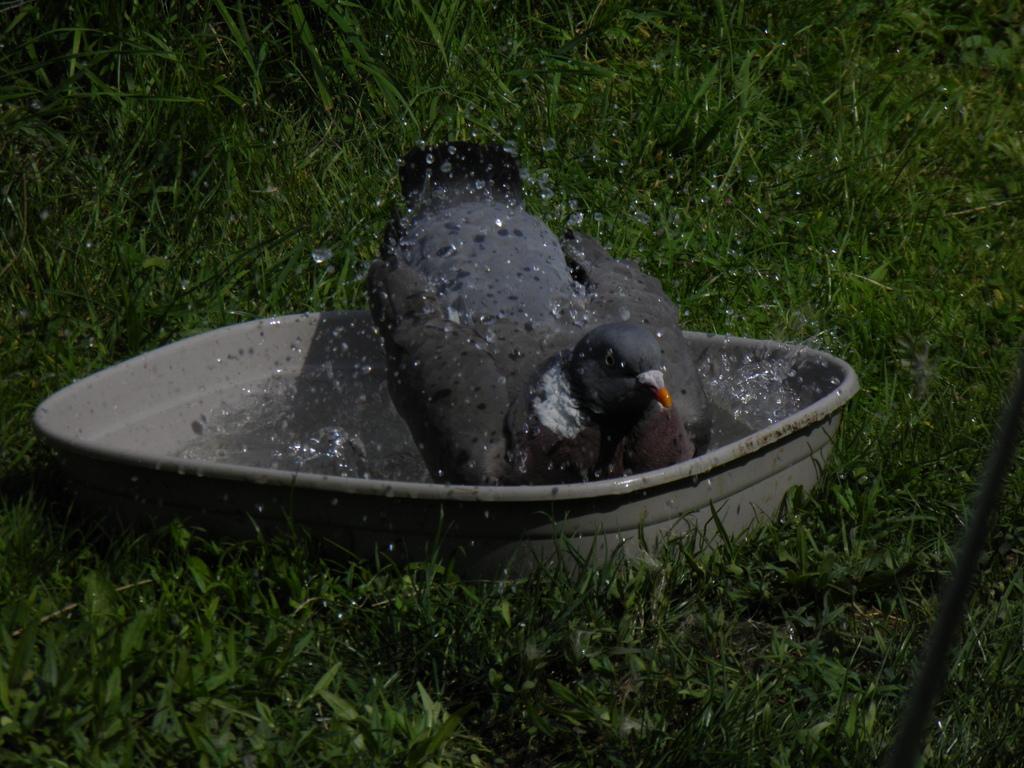Please provide a concise description of this image. In this image we can see a bird, it is in black color, here is the container, and water in it, here is the grass. 